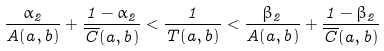Convert formula to latex. <formula><loc_0><loc_0><loc_500><loc_500>\frac { \alpha _ { 2 } } { A ( a , b ) } + \frac { 1 - \alpha _ { 2 } } { \overline { C } ( a , b ) } < \frac { 1 } { T ( a , b ) } < \frac { \beta _ { 2 } } { A ( a , b ) } + \frac { 1 - \beta _ { 2 } } { \overline { C } ( a , b ) }</formula> 